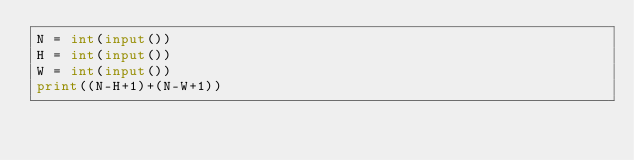<code> <loc_0><loc_0><loc_500><loc_500><_Python_>N = int(input())
H = int(input())
W = int(input())
print((N-H+1)+(N-W+1))
</code> 